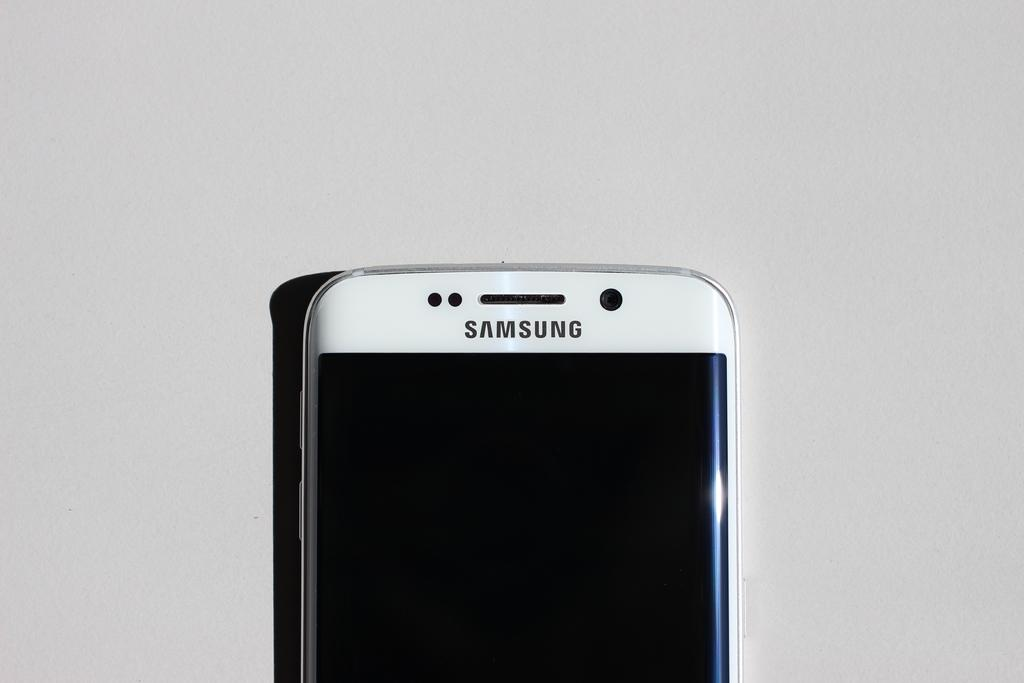<image>
Create a compact narrative representing the image presented. The top of a white Samsung phone laying on a counter top. 